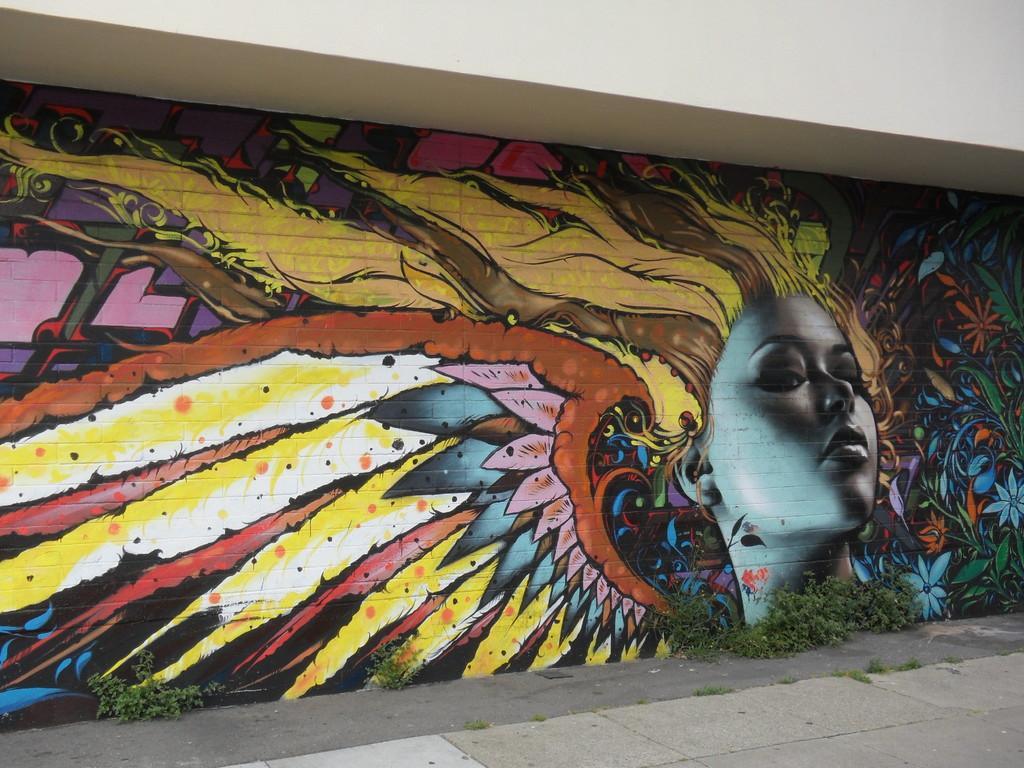Please provide a concise description of this image. In this image there is a wall on which there is a painting of a woman. 